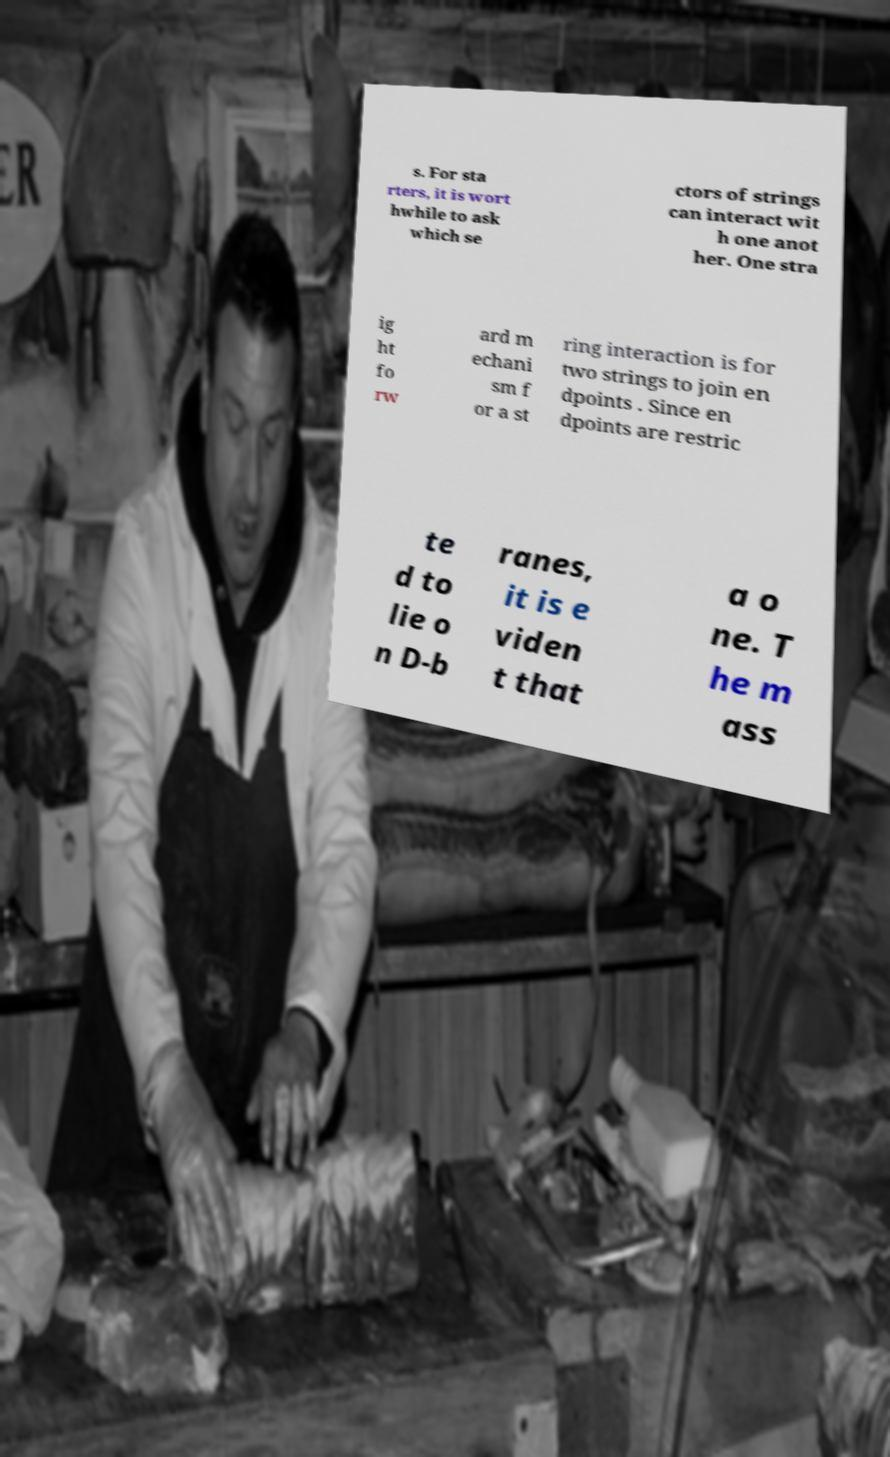Can you read and provide the text displayed in the image?This photo seems to have some interesting text. Can you extract and type it out for me? s. For sta rters, it is wort hwhile to ask which se ctors of strings can interact wit h one anot her. One stra ig ht fo rw ard m echani sm f or a st ring interaction is for two strings to join en dpoints . Since en dpoints are restric te d to lie o n D-b ranes, it is e viden t that a o ne. T he m ass 